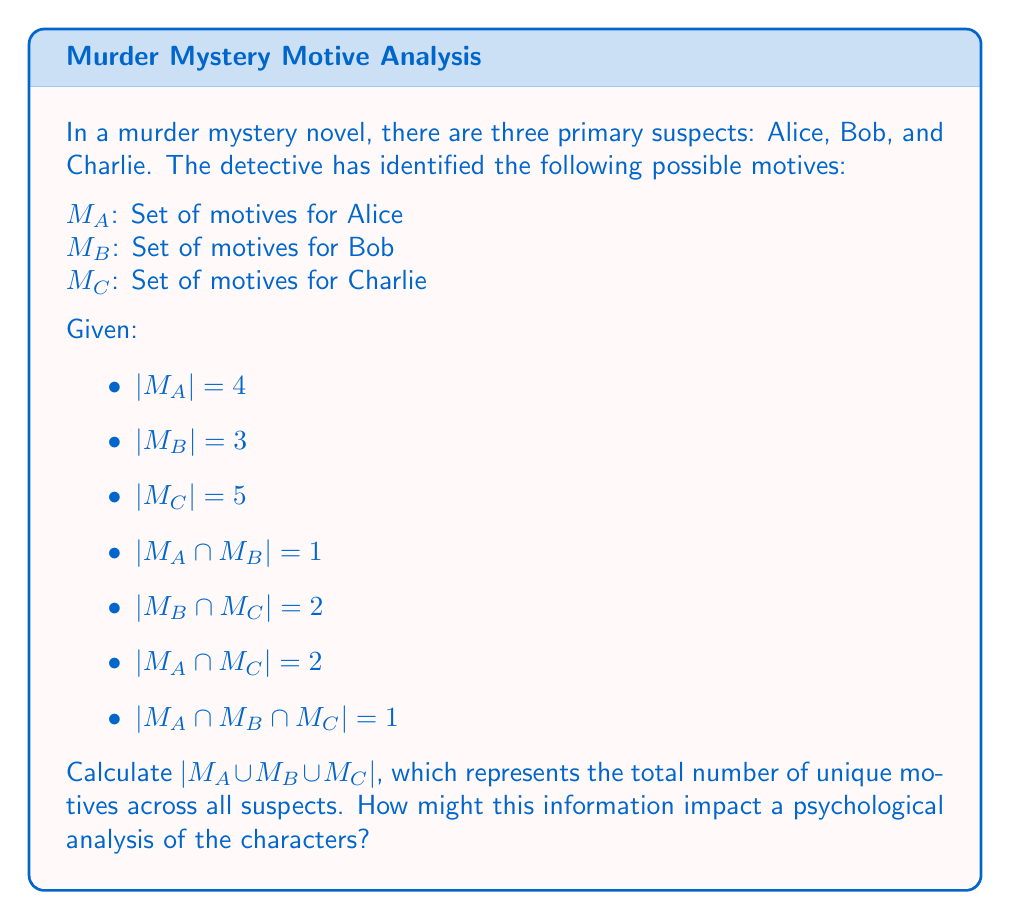Provide a solution to this math problem. To solve this problem, we'll use the Inclusion-Exclusion Principle for three sets:

$$|A \cup B \cup C| = |A| + |B| + |C| - |A \cap B| - |B \cap C| - |A \cap C| + |A \cap B \cap C|$$

Let's substitute the given values:

1) $|M_A| = 4$
2) $|M_B| = 3$
3) $|M_C| = 5$
4) $|M_A \cap M_B| = 1$
5) $|M_B \cap M_C| = 2$
6) $|M_A \cap M_C| = 2$
7) $|M_A \cap M_B \cap M_C| = 1$

Now, let's apply the formula:

$$|M_A \cup M_B \cup M_C| = 4 + 3 + 5 - 1 - 2 - 2 + 1 = 8$$

From a psychological perspective, this result indicates that there are 8 unique motives across all suspects. This information can be valuable for character analysis:

1) It shows the complexity of the case, as there are multiple motives involved.
2) The overlap in motives (as seen in the intersections) suggests shared experiences or relationships among the suspects.
3) The unique motives for each character can provide insight into their individual psychologies and potential reasons for committing the crime.
4) The total number of motives (8) compared to the individual sets (4, 3, and 5) indicates that some motives are shared, which could point to a collective psychological factor influencing the characters.
Answer: $|M_A \cup M_B \cup M_C| = 8$ 